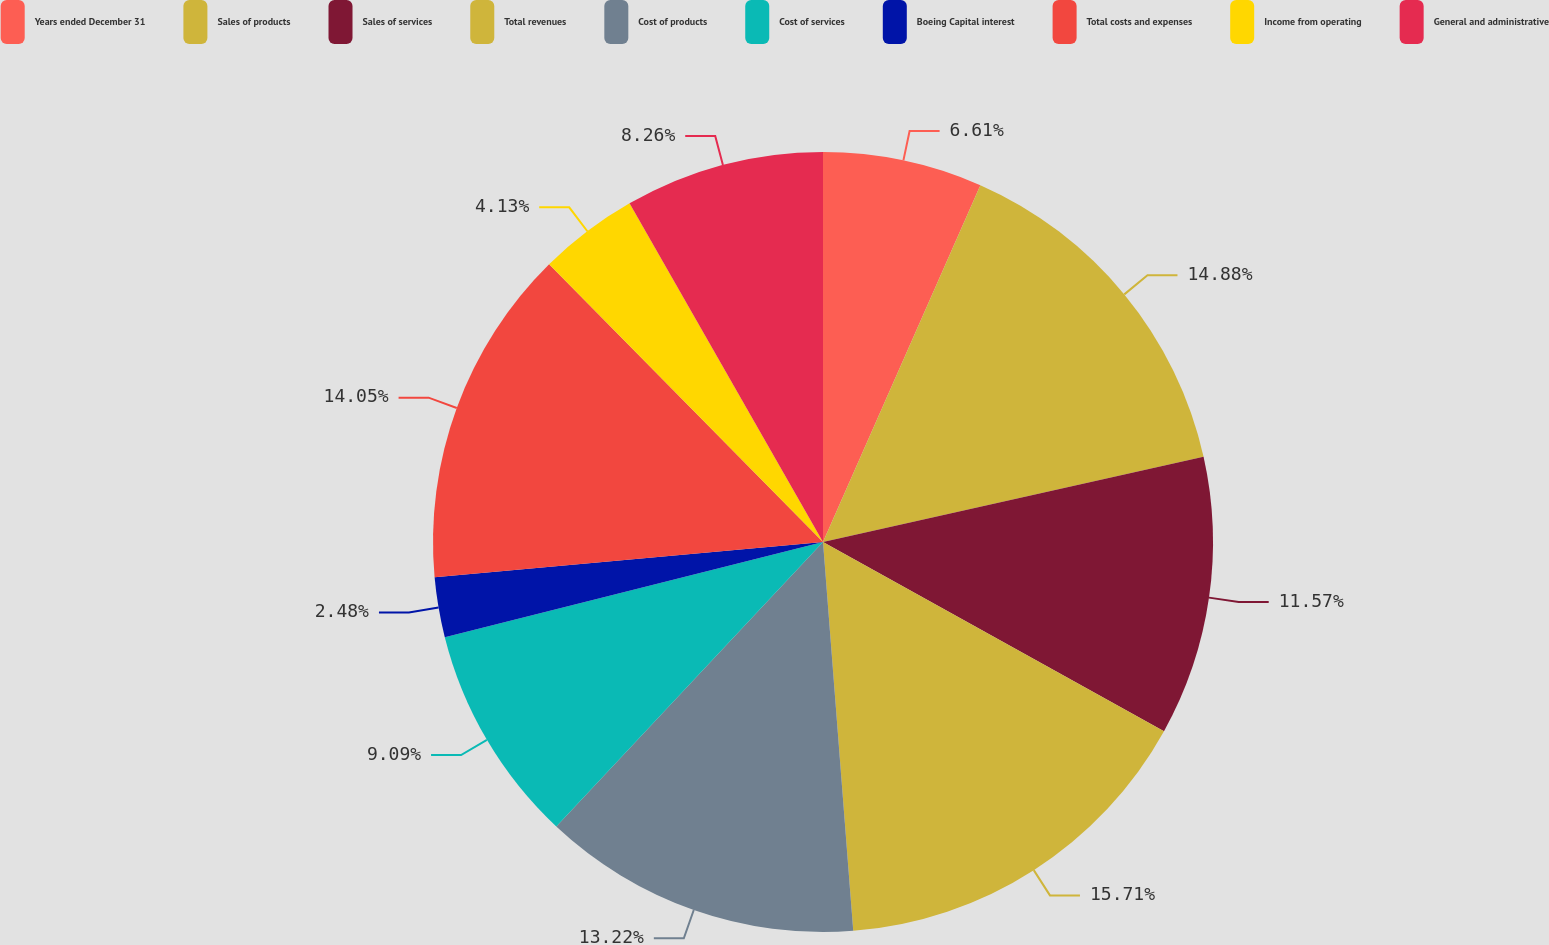Convert chart to OTSL. <chart><loc_0><loc_0><loc_500><loc_500><pie_chart><fcel>Years ended December 31<fcel>Sales of products<fcel>Sales of services<fcel>Total revenues<fcel>Cost of products<fcel>Cost of services<fcel>Boeing Capital interest<fcel>Total costs and expenses<fcel>Income from operating<fcel>General and administrative<nl><fcel>6.61%<fcel>14.88%<fcel>11.57%<fcel>15.7%<fcel>13.22%<fcel>9.09%<fcel>2.48%<fcel>14.05%<fcel>4.13%<fcel>8.26%<nl></chart> 